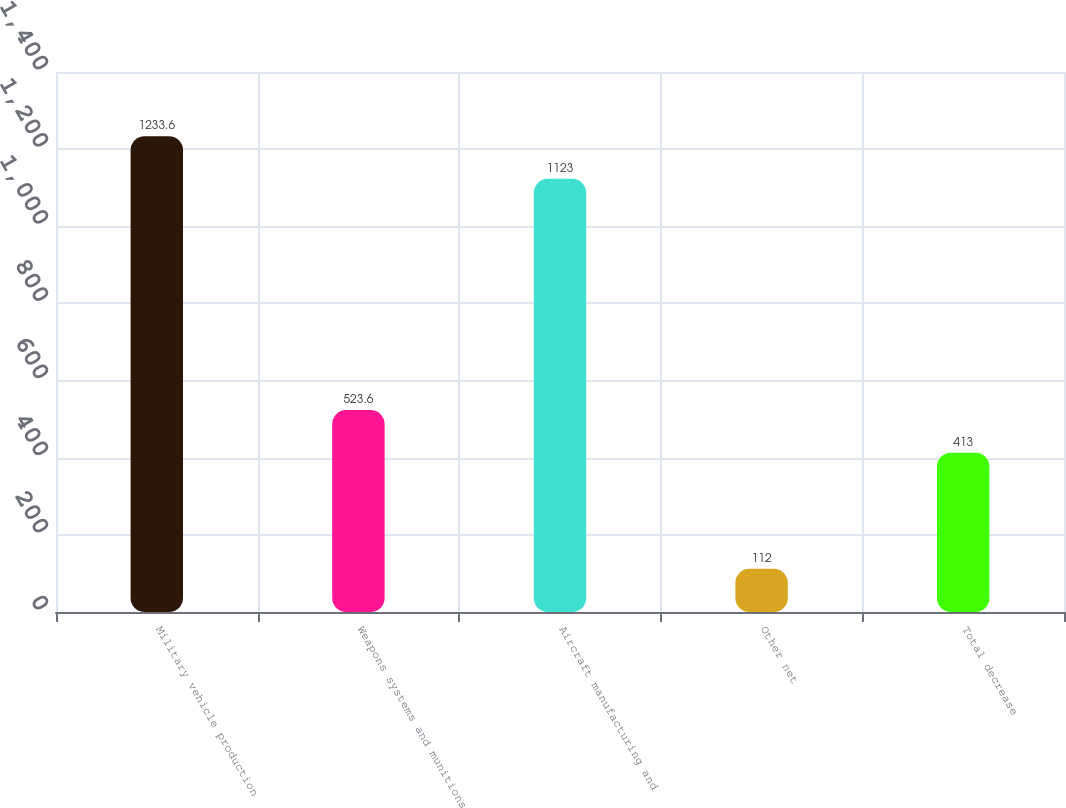Convert chart. <chart><loc_0><loc_0><loc_500><loc_500><bar_chart><fcel>Military vehicle production<fcel>Weapons systems and munitions<fcel>Aircraft manufacturing and<fcel>Other net<fcel>Total decrease<nl><fcel>1233.6<fcel>523.6<fcel>1123<fcel>112<fcel>413<nl></chart> 